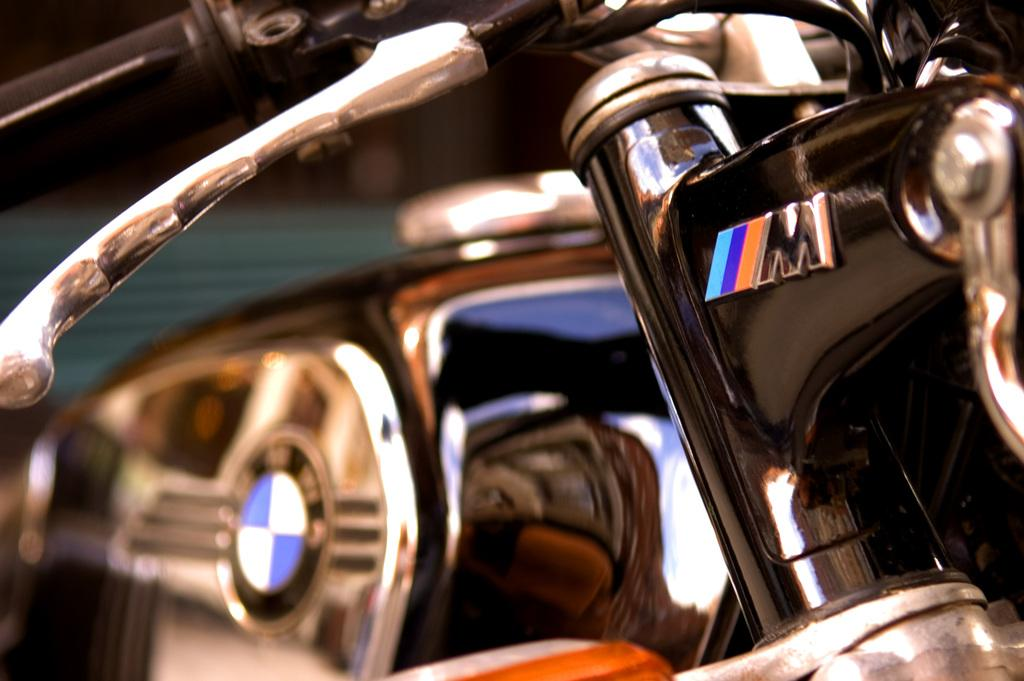What is the main subject of the image? The main subject of the image is a part of a motorbike. Can you describe the background of the image? The background of the image is blurry. How many balls are visible in the image? There are no balls present in the image; it features a part of a motorbike and a blurry background. 